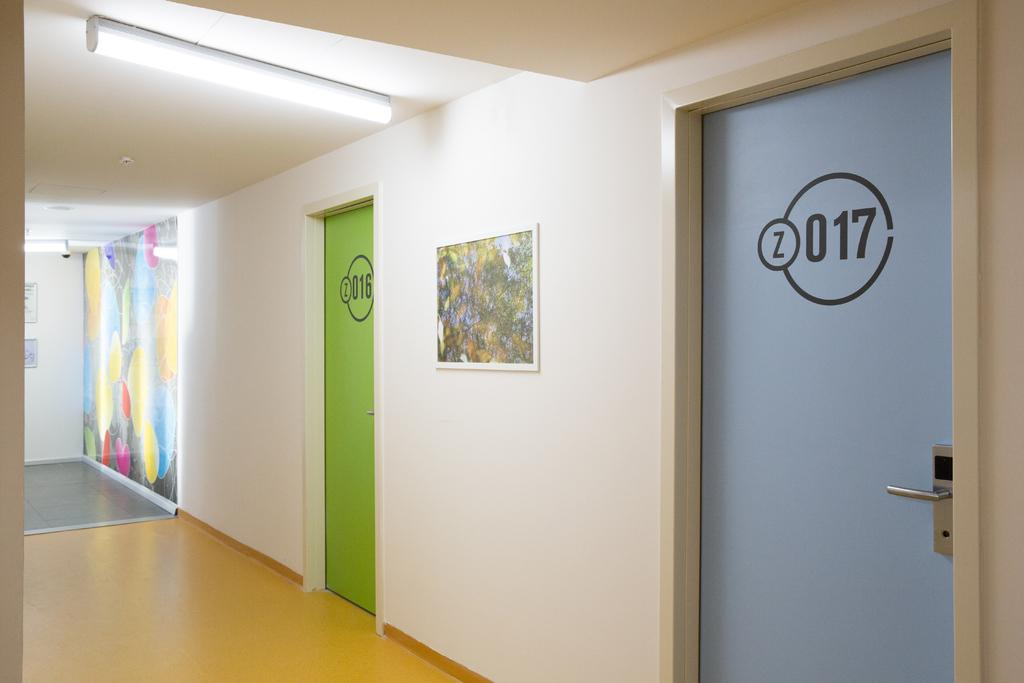What is the color of the wall in the image? The wall in the image is white. What can be used to enter or exit a room in the image? There are doors in the image. What is used to display a picture in the image? There is a photo frame in the image. What provides illumination in the image? There are lights in the image. Can you hear the voice of the sea in the image? There is no reference to a sea or any sounds in the image, so it's not possible to determine if a voice can be heard. 